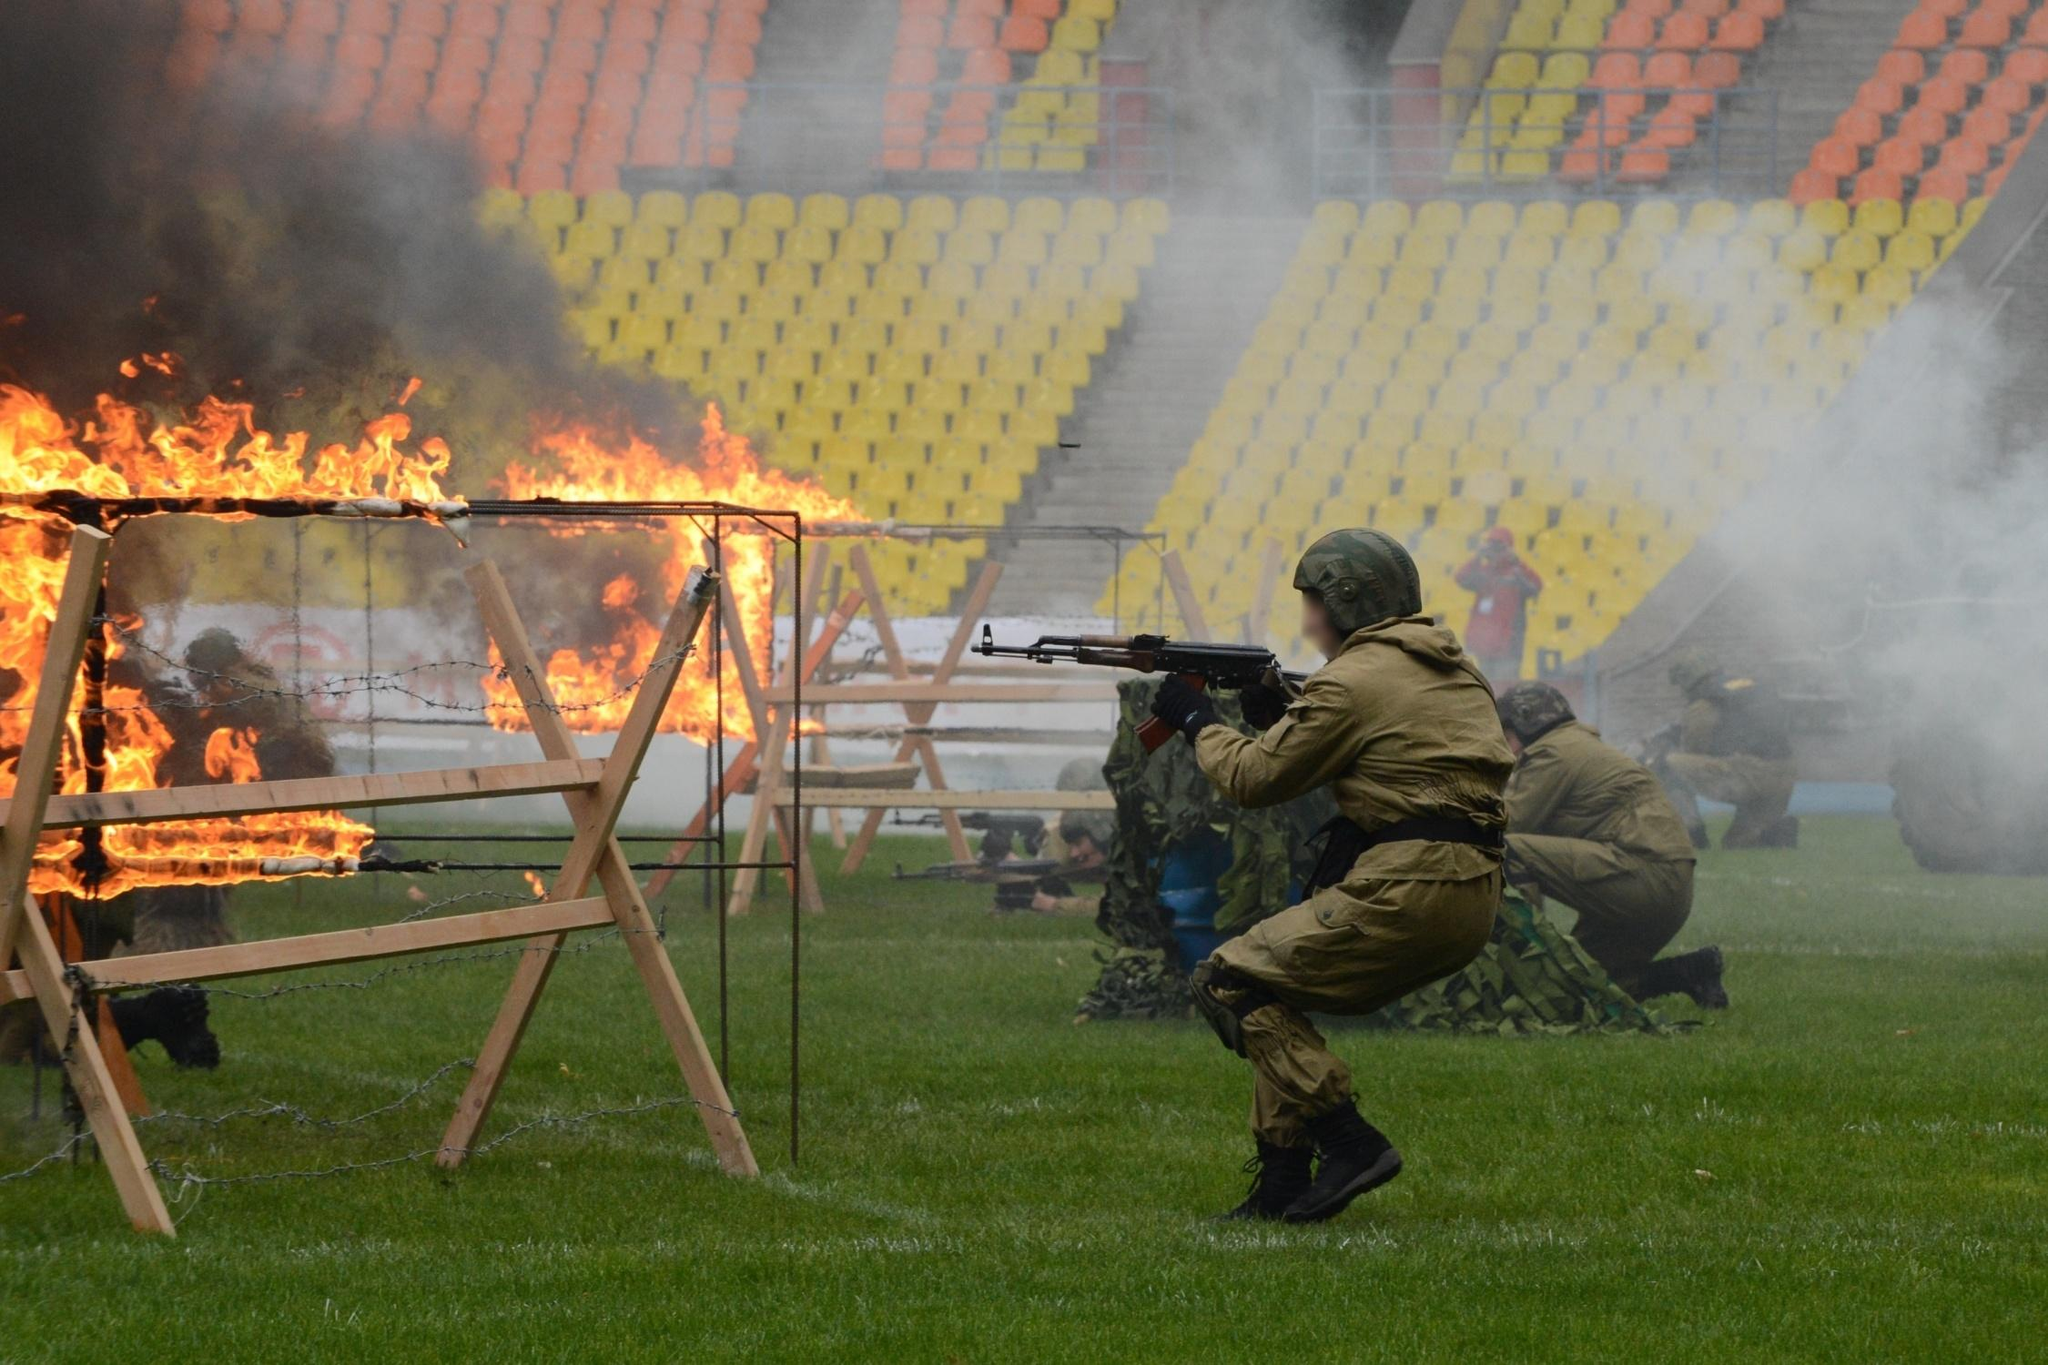Can you describe the main features of this image for me? The image vividly captures a military drill on a football field engulfed in smoke and flames, likely a simulation aimed at preparing soldiers for combat scenarios. In detailed foreground, uniformed soldiers in green camouflage are actively engaging with the scene, each poised and aiming rifles towards strategic points on the field among fiery obstacles, emphasizing the intensity and seriousness of their training. The background starkly contrasts the activity with rows of empty, brightly colored stadium seats, accentuating the starkness of the simulation environment. The absence of spectators and the soldiers’ focus underscore the gravity of their preparation for real-world challenges. 